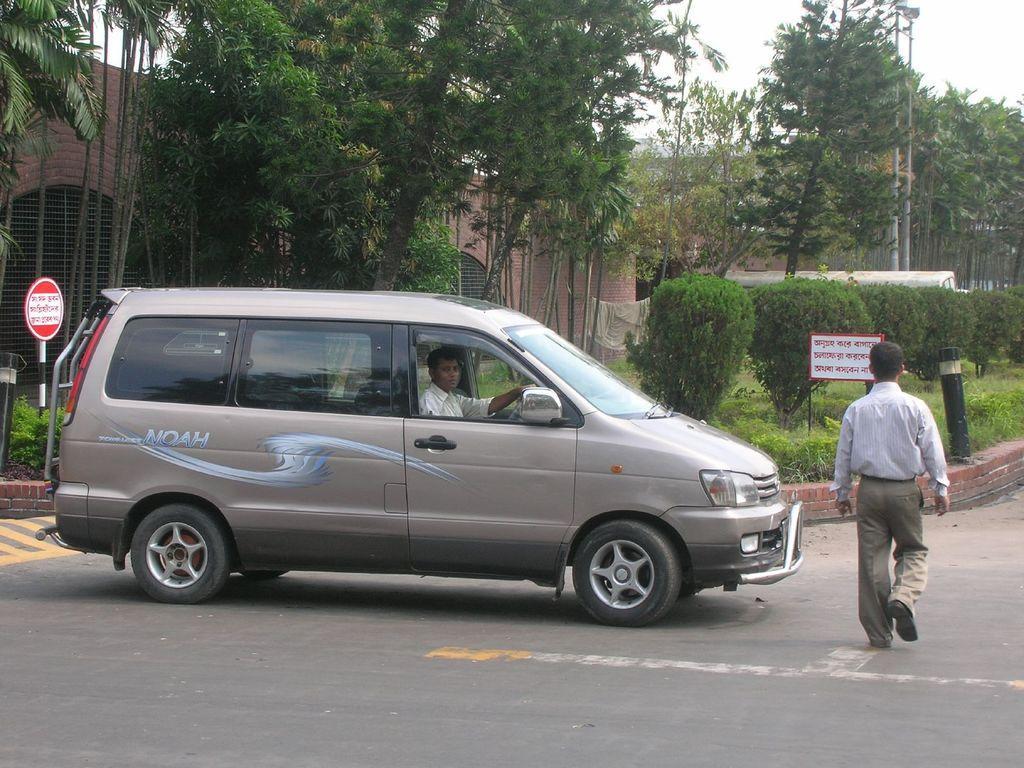How would you summarize this image in a sentence or two? On the right a person is walking on the road next to him a person is coming towards him riding a vehicle. In the background there are trees,building,plants,sign board,poles and sky. 